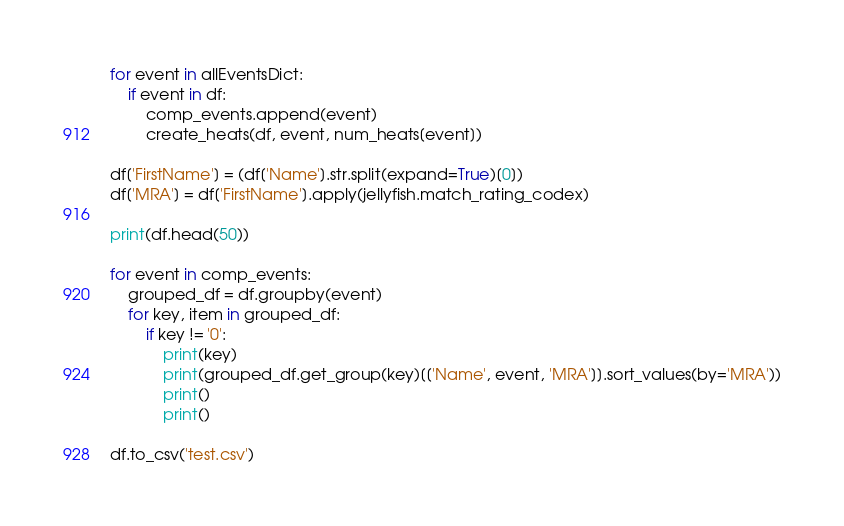<code> <loc_0><loc_0><loc_500><loc_500><_Python_>
for event in allEventsDict:
    if event in df:
        comp_events.append(event)
        create_heats(df, event, num_heats[event])

df['FirstName'] = (df['Name'].str.split(expand=True)[0])
df['MRA'] = df['FirstName'].apply(jellyfish.match_rating_codex)

print(df.head(50))

for event in comp_events:
    grouped_df = df.groupby(event)
    for key, item in grouped_df:
        if key != '0':
            print(key)
            print(grouped_df.get_group(key)[['Name', event, 'MRA']].sort_values(by='MRA'))
            print()
            print()

df.to_csv('test.csv')</code> 